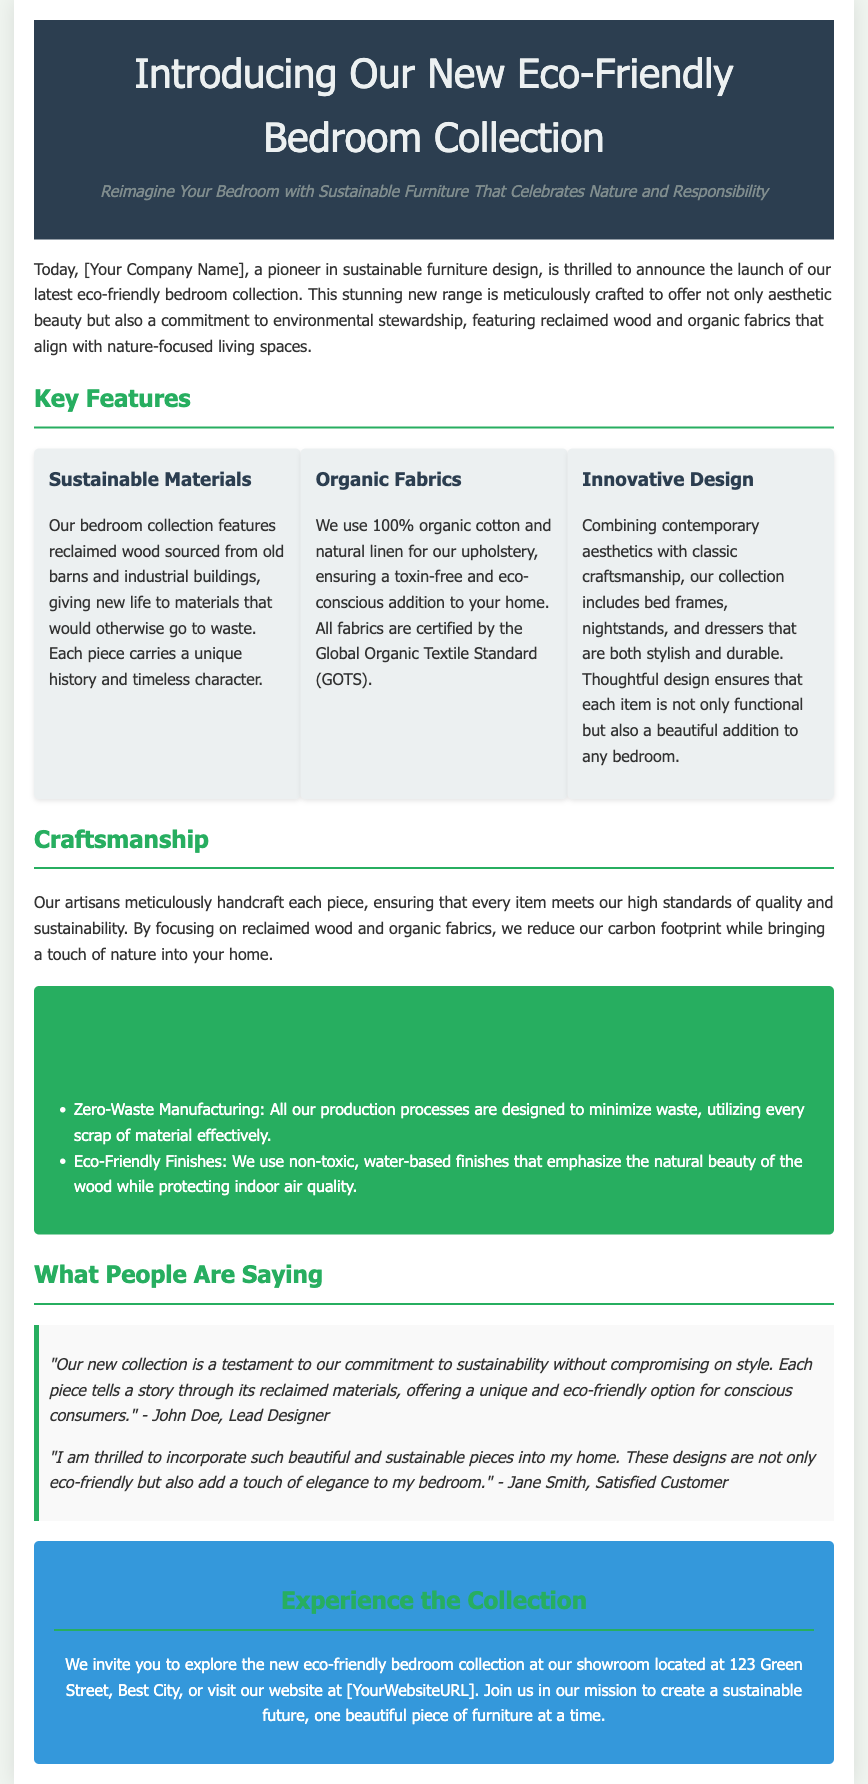What is the name of the new collection? The new collection is referred to as the Eco-Friendly Bedroom Collection.
Answer: Eco-Friendly Bedroom Collection What type of wood is used in the collection? The collection features reclaimed wood sourced from old barns and industrial buildings.
Answer: Reclaimed wood What certification do the organic fabrics have? The organic fabrics used in the collection are certified by the Global Organic Textile Standard.
Answer: Global Organic Textile Standard How many key features are highlighted in the press release? The press release highlights three key features of the collection.
Answer: Three Who is the Lead Designer mentioned in the quotes? The Lead Designer mentioned in the quotes is John Doe.
Answer: John Doe What is the address of the showroom? The showroom is located at 123 Green Street, Best City.
Answer: 123 Green Street, Best City What manufacturing policy does the company follow? The company follows a zero-waste manufacturing policy.
Answer: Zero-Waste Manufacturing What type of finishes are used on the furniture? The furniture is finished with non-toxic, water-based finishes.
Answer: Non-toxic, water-based finishes 